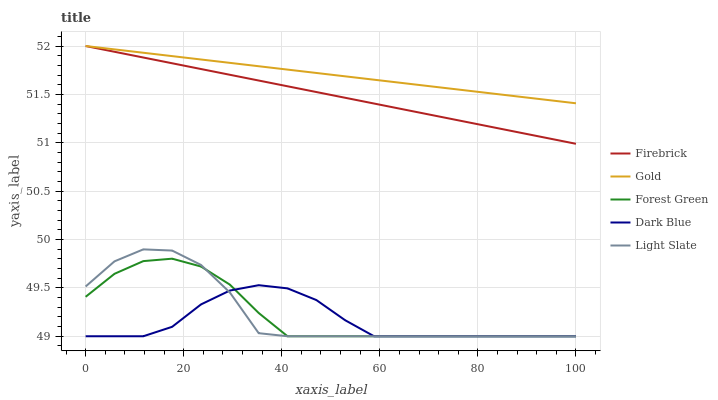Does Dark Blue have the minimum area under the curve?
Answer yes or no. Yes. Does Gold have the maximum area under the curve?
Answer yes or no. Yes. Does Firebrick have the minimum area under the curve?
Answer yes or no. No. Does Firebrick have the maximum area under the curve?
Answer yes or no. No. Is Gold the smoothest?
Answer yes or no. Yes. Is Light Slate the roughest?
Answer yes or no. Yes. Is Dark Blue the smoothest?
Answer yes or no. No. Is Dark Blue the roughest?
Answer yes or no. No. Does Light Slate have the lowest value?
Answer yes or no. Yes. Does Firebrick have the lowest value?
Answer yes or no. No. Does Gold have the highest value?
Answer yes or no. Yes. Does Dark Blue have the highest value?
Answer yes or no. No. Is Dark Blue less than Firebrick?
Answer yes or no. Yes. Is Gold greater than Dark Blue?
Answer yes or no. Yes. Does Firebrick intersect Gold?
Answer yes or no. Yes. Is Firebrick less than Gold?
Answer yes or no. No. Is Firebrick greater than Gold?
Answer yes or no. No. Does Dark Blue intersect Firebrick?
Answer yes or no. No. 